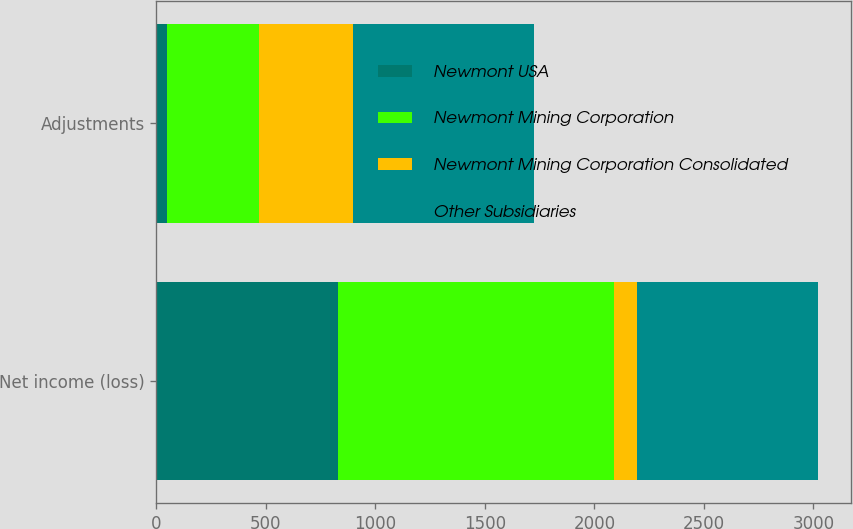<chart> <loc_0><loc_0><loc_500><loc_500><stacked_bar_chart><ecel><fcel>Net income (loss)<fcel>Adjustments<nl><fcel>Newmont USA<fcel>831<fcel>49<nl><fcel>Newmont Mining Corporation<fcel>1259<fcel>419<nl><fcel>Newmont Mining Corporation Consolidated<fcel>104<fcel>430<nl><fcel>Other Subsidiaries<fcel>826<fcel>826<nl></chart> 